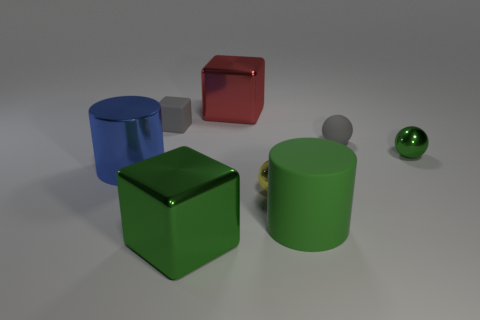Subtract all blue blocks. Subtract all green balls. How many blocks are left? 3 Add 2 small green objects. How many objects exist? 10 Subtract all cylinders. How many objects are left? 6 Add 7 tiny gray balls. How many tiny gray balls are left? 8 Add 4 green objects. How many green objects exist? 7 Subtract 0 brown cubes. How many objects are left? 8 Subtract all yellow spheres. Subtract all tiny green metallic balls. How many objects are left? 6 